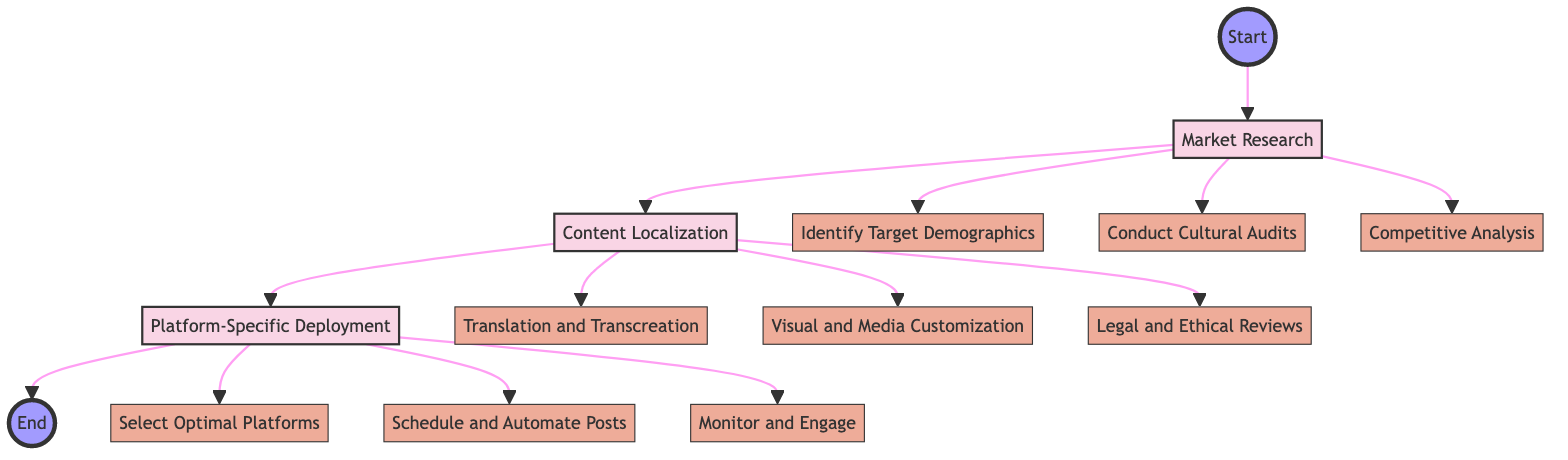What are the three main stages in the diagram? The diagram lists Market Research, Content Localization, and Platform-Specific Deployment as the primary stages of the process.
Answer: Market Research, Content Localization, Platform-Specific Deployment What is the first step in Market Research? The first step outlined under Market Research is "Identify Target Demographics", which comes directly after the Market Research node in the flowchart.
Answer: Identify Target Demographics Which tools are suggested for conducting Cultural Audits? The tools suggested for this step, as displayed in the flowchart, are Ethnographic Studies and Local Experts; they are listed under the "Conduct Cultural Audits" step.
Answer: Ethnographic Studies, Local Experts How many steps are there under the Content Localization stage? There are three steps listed under the Content Localization stage as indicated by the flowchart.
Answer: 3 What is the last step in the diagram? According to the flowchart, the last stage of the process flow is "Monitor and Engage," which is the final step under Platform-Specific Deployment.
Answer: Monitor and Engage What is the relationship between Content Localization and Platform-Specific Deployment? Content Localization follows directly after Market Research in the flowchart and precedes Platform-Specific Deployment, indicating a sequential relationship where Content Localization is a prerequisite for Platform-Specific Deployment.
Answer: Sequential relationship Which tools are recommended for selecting optimal platforms? The tools indicated for this step in the flowchart include Sprout Social and Hootsuite, highlighting the resources available for selecting the best platforms for deployment.
Answer: Sprout Social, Hootsuite What stage involves adapting content to resonate with diverse cultures? The stage that focuses on this aspect is called Content Localization, which explicitly mentions the need for adaptation in its description.
Answer: Content Localization Which tools are used for scheduling and automating posts? The tools highlighted for this purpose in the diagram are Buffer and Later, as listed under the "Schedule and Automate Posts" step.
Answer: Buffer, Later 